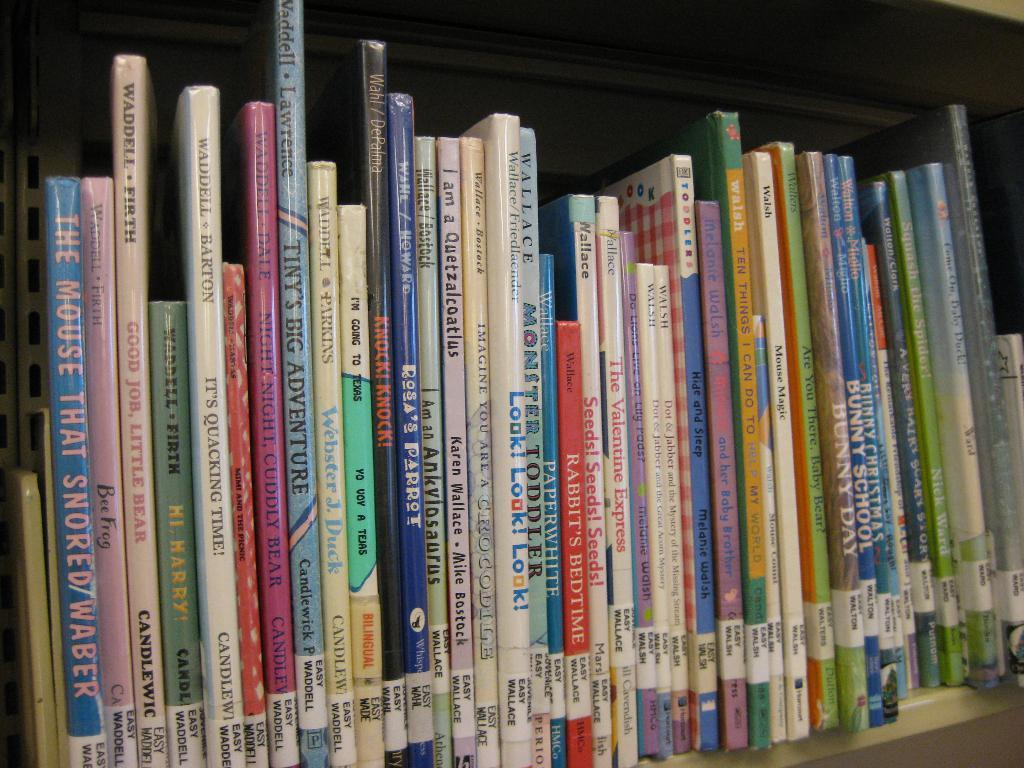<image>
Render a clear and concise summary of the photo. a book that has the word snored on it 